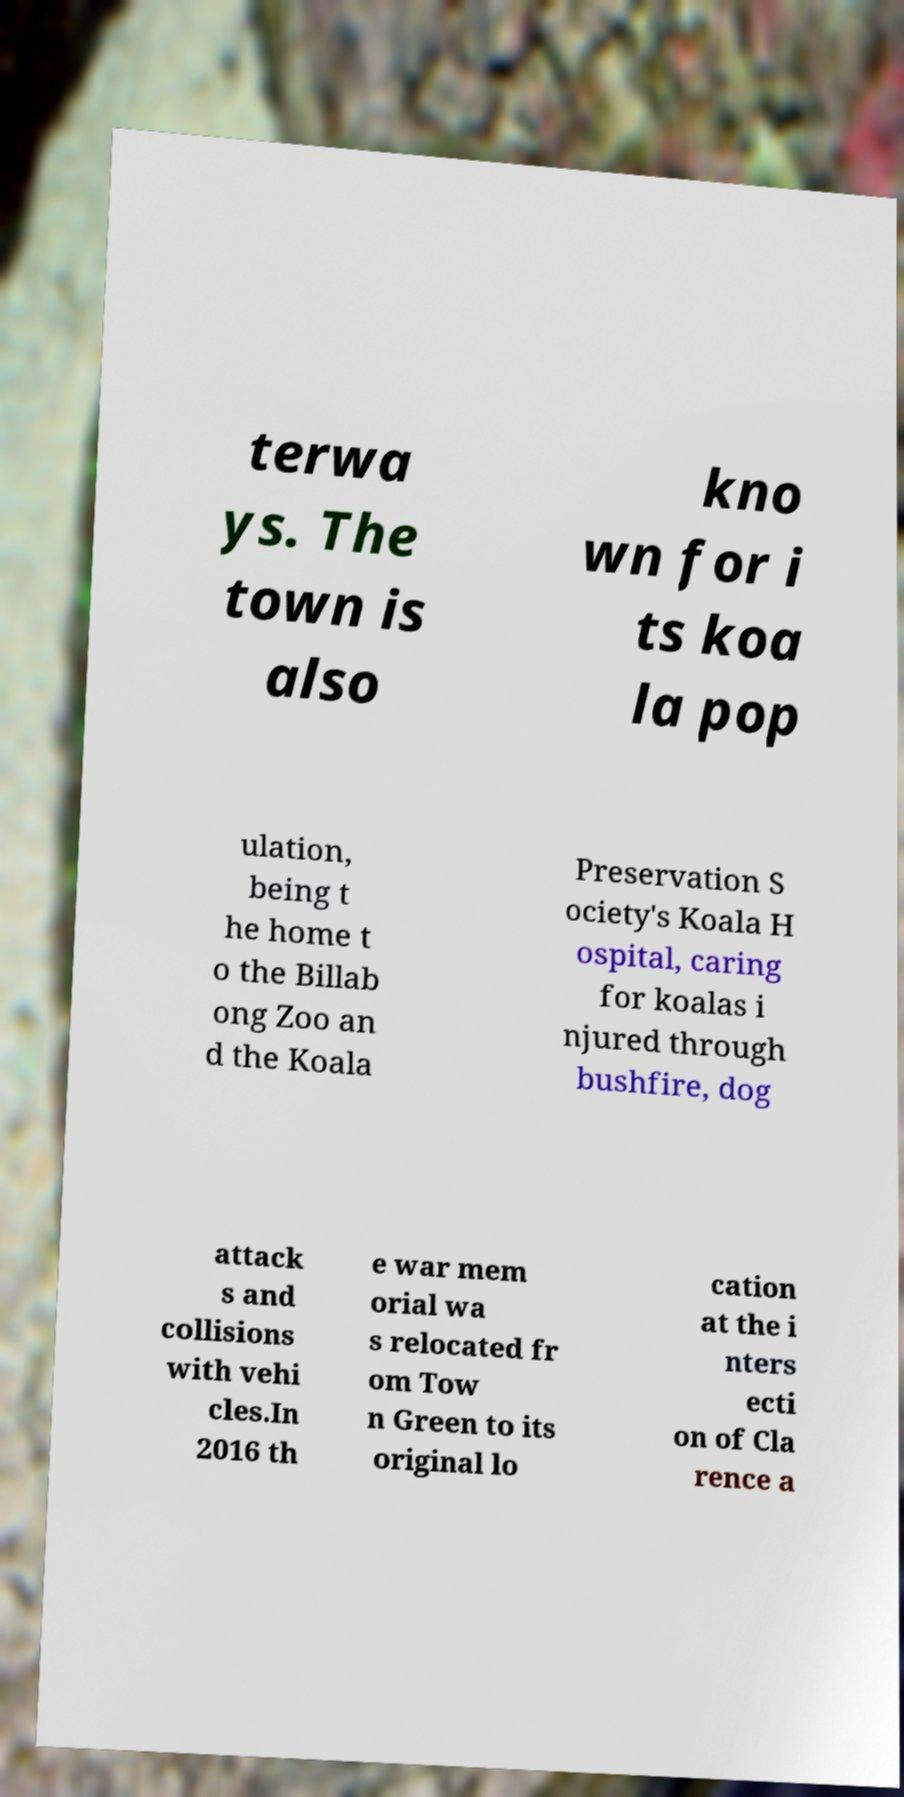Could you extract and type out the text from this image? terwa ys. The town is also kno wn for i ts koa la pop ulation, being t he home t o the Billab ong Zoo an d the Koala Preservation S ociety's Koala H ospital, caring for koalas i njured through bushfire, dog attack s and collisions with vehi cles.In 2016 th e war mem orial wa s relocated fr om Tow n Green to its original lo cation at the i nters ecti on of Cla rence a 